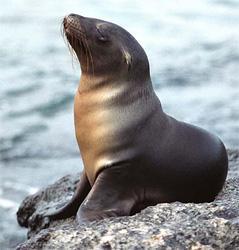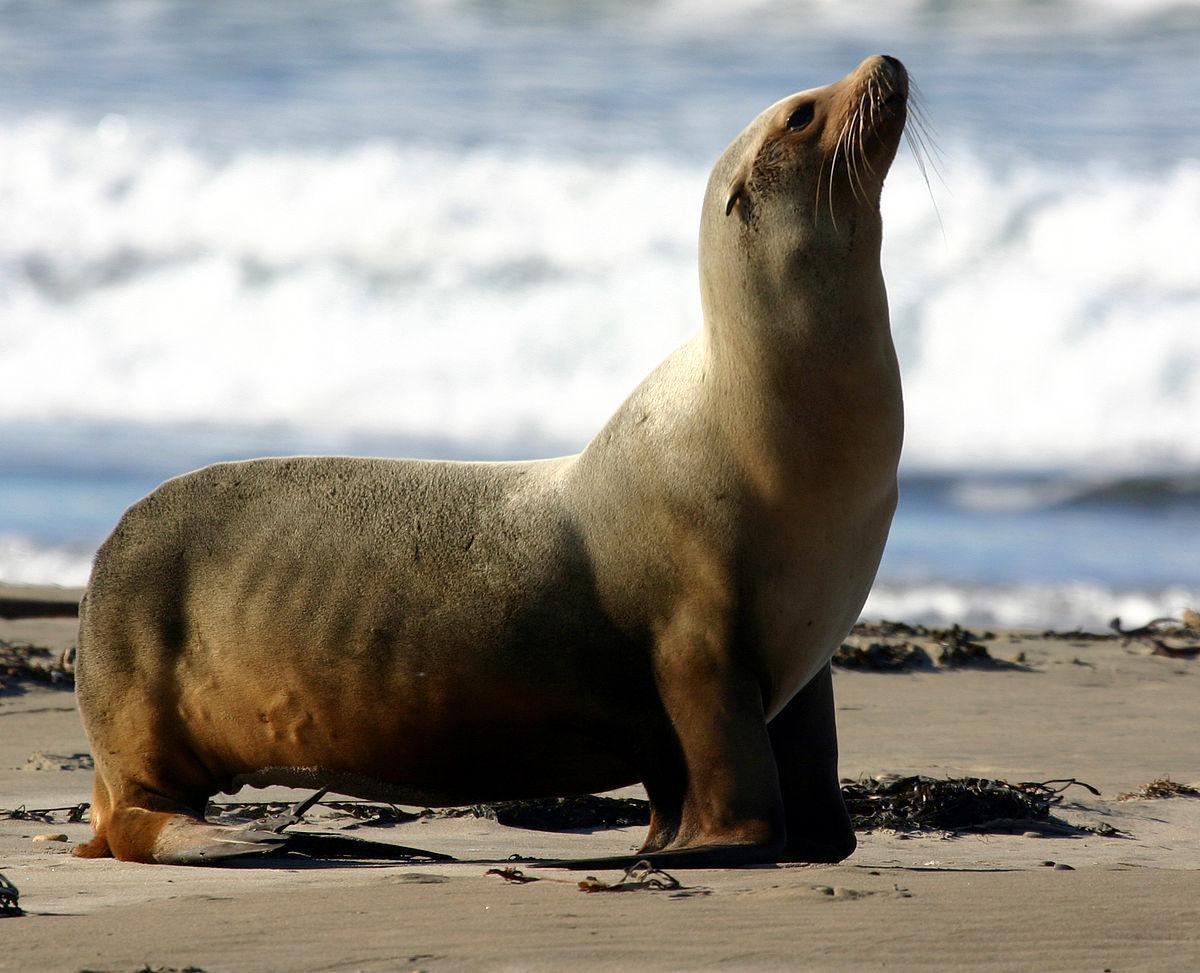The first image is the image on the left, the second image is the image on the right. For the images displayed, is the sentence "A tawny-colored seal is sleeping in at least one of the images." factually correct? Answer yes or no. No. The first image is the image on the left, the second image is the image on the right. Analyze the images presented: Is the assertion "There are no more than two seals." valid? Answer yes or no. Yes. The first image is the image on the left, the second image is the image on the right. Analyze the images presented: Is the assertion "There are two seals" valid? Answer yes or no. Yes. 